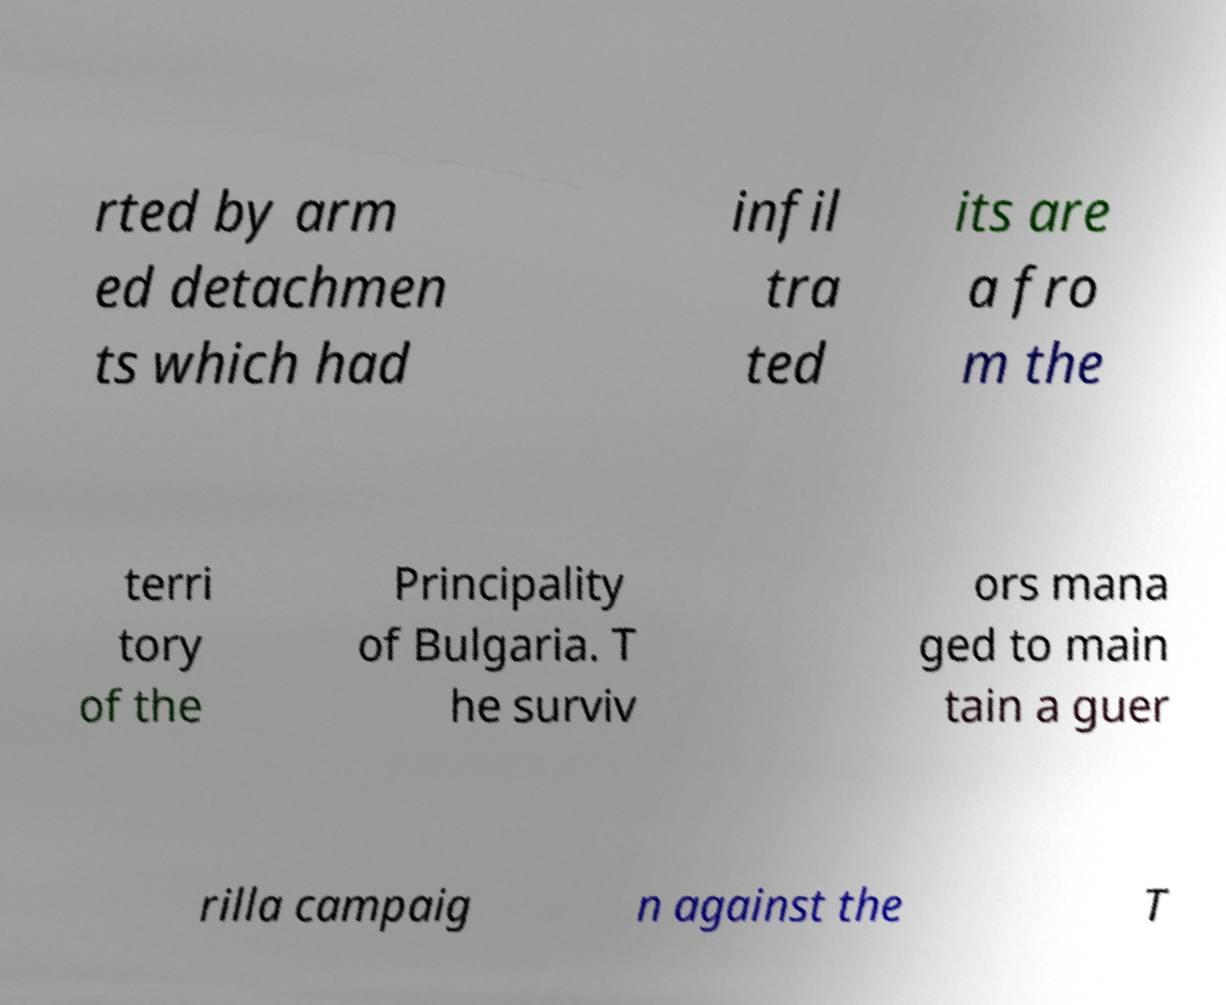Please read and relay the text visible in this image. What does it say? rted by arm ed detachmen ts which had infil tra ted its are a fro m the terri tory of the Principality of Bulgaria. T he surviv ors mana ged to main tain a guer rilla campaig n against the T 